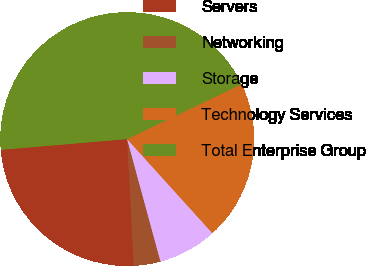Convert chart to OTSL. <chart><loc_0><loc_0><loc_500><loc_500><pie_chart><fcel>Servers<fcel>Networking<fcel>Storage<fcel>Technology Services<fcel>Total Enterprise Group<nl><fcel>24.49%<fcel>3.4%<fcel>7.48%<fcel>20.41%<fcel>44.22%<nl></chart> 